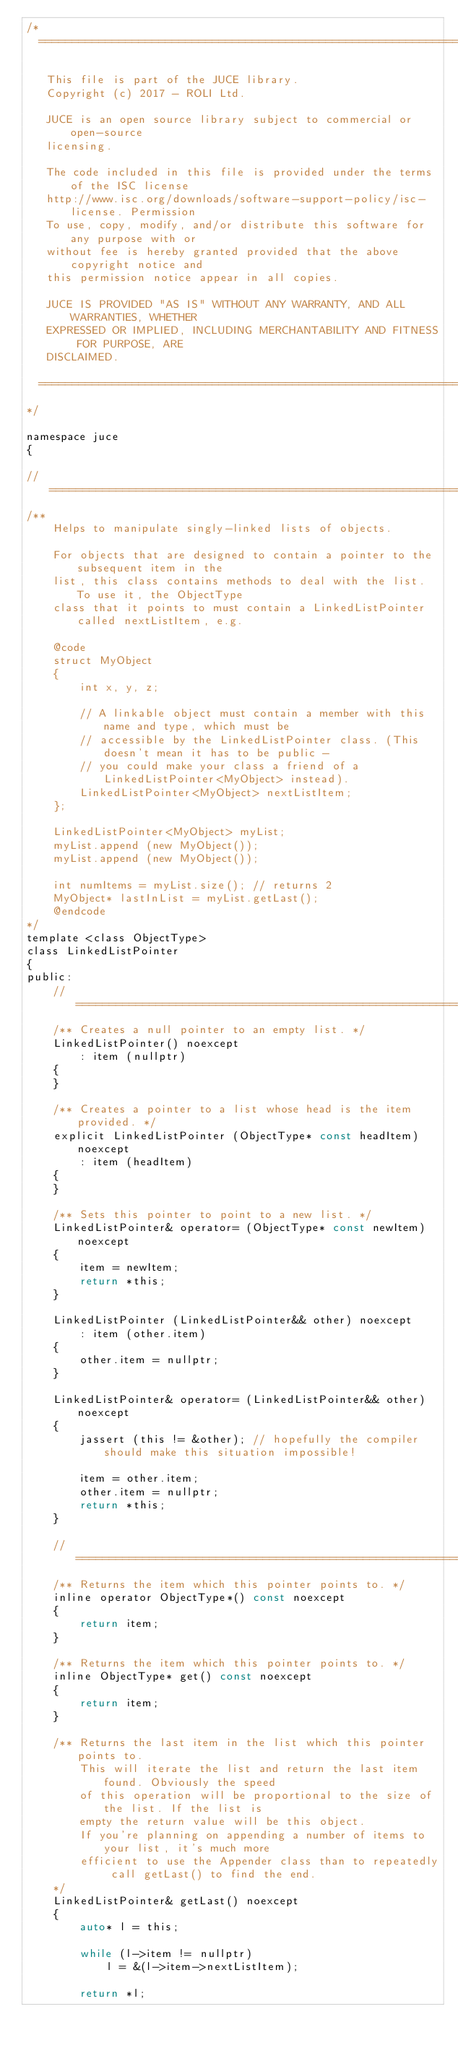<code> <loc_0><loc_0><loc_500><loc_500><_C_>/*
  ==============================================================================

   This file is part of the JUCE library.
   Copyright (c) 2017 - ROLI Ltd.

   JUCE is an open source library subject to commercial or open-source
   licensing.

   The code included in this file is provided under the terms of the ISC license
   http://www.isc.org/downloads/software-support-policy/isc-license. Permission
   To use, copy, modify, and/or distribute this software for any purpose with or
   without fee is hereby granted provided that the above copyright notice and
   this permission notice appear in all copies.

   JUCE IS PROVIDED "AS IS" WITHOUT ANY WARRANTY, AND ALL WARRANTIES, WHETHER
   EXPRESSED OR IMPLIED, INCLUDING MERCHANTABILITY AND FITNESS FOR PURPOSE, ARE
   DISCLAIMED.

  ==============================================================================
*/

namespace juce
{

//==============================================================================
/**
    Helps to manipulate singly-linked lists of objects.

    For objects that are designed to contain a pointer to the subsequent item in the
    list, this class contains methods to deal with the list. To use it, the ObjectType
    class that it points to must contain a LinkedListPointer called nextListItem, e.g.

    @code
    struct MyObject
    {
        int x, y, z;

        // A linkable object must contain a member with this name and type, which must be
        // accessible by the LinkedListPointer class. (This doesn't mean it has to be public -
        // you could make your class a friend of a LinkedListPointer<MyObject> instead).
        LinkedListPointer<MyObject> nextListItem;
    };

    LinkedListPointer<MyObject> myList;
    myList.append (new MyObject());
    myList.append (new MyObject());

    int numItems = myList.size(); // returns 2
    MyObject* lastInList = myList.getLast();
    @endcode
*/
template <class ObjectType>
class LinkedListPointer
{
public:
    //==============================================================================
    /** Creates a null pointer to an empty list. */
    LinkedListPointer() noexcept
        : item (nullptr)
    {
    }

    /** Creates a pointer to a list whose head is the item provided. */
    explicit LinkedListPointer (ObjectType* const headItem) noexcept
        : item (headItem)
    {
    }

    /** Sets this pointer to point to a new list. */
    LinkedListPointer& operator= (ObjectType* const newItem) noexcept
    {
        item = newItem;
        return *this;
    }

    LinkedListPointer (LinkedListPointer&& other) noexcept
        : item (other.item)
    {
        other.item = nullptr;
    }

    LinkedListPointer& operator= (LinkedListPointer&& other) noexcept
    {
        jassert (this != &other); // hopefully the compiler should make this situation impossible!

        item = other.item;
        other.item = nullptr;
        return *this;
    }

    //==============================================================================
    /** Returns the item which this pointer points to. */
    inline operator ObjectType*() const noexcept
    {
        return item;
    }

    /** Returns the item which this pointer points to. */
    inline ObjectType* get() const noexcept
    {
        return item;
    }

    /** Returns the last item in the list which this pointer points to.
        This will iterate the list and return the last item found. Obviously the speed
        of this operation will be proportional to the size of the list. If the list is
        empty the return value will be this object.
        If you're planning on appending a number of items to your list, it's much more
        efficient to use the Appender class than to repeatedly call getLast() to find the end.
    */
    LinkedListPointer& getLast() noexcept
    {
        auto* l = this;

        while (l->item != nullptr)
            l = &(l->item->nextListItem);

        return *l;</code> 